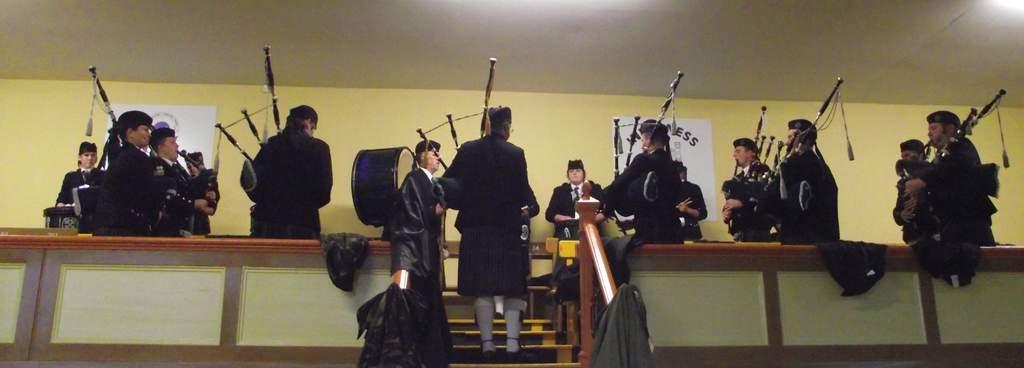In one or two sentences, can you explain what this image depicts? In this picture we can see many people standing and playing bagpipes. They are wearing black uniform and white socks with a cap. 